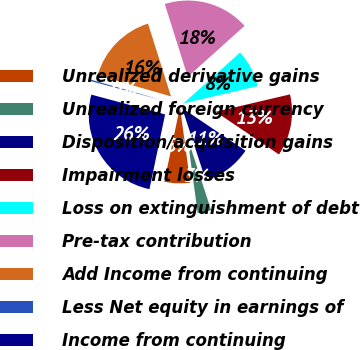Convert chart to OTSL. <chart><loc_0><loc_0><loc_500><loc_500><pie_chart><fcel>Unrealized derivative gains<fcel>Unrealized foreign currency<fcel>Disposition/acquisition gains<fcel>Impairment losses<fcel>Loss on extinguishment of debt<fcel>Pre-tax contribution<fcel>Add Income from continuing<fcel>Less Net equity in earnings of<fcel>Income from continuing<nl><fcel>5.43%<fcel>2.87%<fcel>10.54%<fcel>13.1%<fcel>7.99%<fcel>18.22%<fcel>15.66%<fcel>0.31%<fcel>25.89%<nl></chart> 